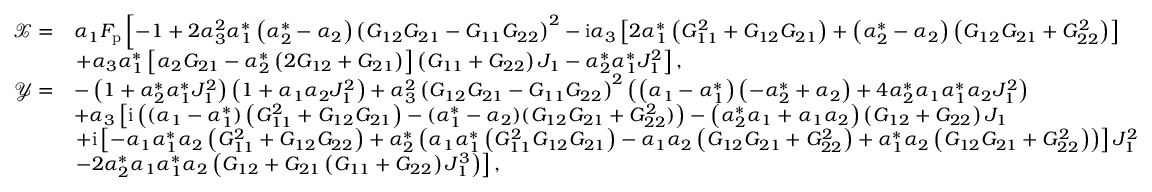<formula> <loc_0><loc_0><loc_500><loc_500>\begin{array} { r l } { \mathcal { X } = } & { \alpha _ { 1 } F _ { p } \left [ - 1 + 2 \alpha _ { 3 } ^ { 2 } \alpha _ { 1 } ^ { * } \left ( \alpha _ { 2 } ^ { * } - \alpha _ { 2 } \right ) \left ( G _ { 1 2 } G _ { 2 1 } - G _ { 1 1 } G _ { 2 2 } \right ) ^ { 2 } - i \alpha _ { 3 } \left [ 2 \alpha _ { 1 } ^ { * } \left ( G _ { 1 1 } ^ { 2 } + G _ { 1 2 } G _ { 2 1 } \right ) + \left ( \alpha _ { 2 } ^ { * } - \alpha _ { 2 } \right ) \left ( G _ { 1 2 } G _ { 2 1 } + G _ { 2 2 } ^ { 2 } \right ) \right ] } \\ & { + \alpha _ { 3 } \alpha _ { 1 } ^ { * } \left [ \alpha _ { 2 } G _ { 2 1 } - \alpha _ { 2 } ^ { * } \left ( 2 G _ { 1 2 } + G _ { 2 1 } \right ) \right ] \left ( G _ { 1 1 } + G _ { 2 2 } \right ) J _ { 1 } - \alpha _ { 2 } ^ { * } \alpha _ { 1 } ^ { * } J _ { 1 } ^ { 2 } \right ] , } \\ { \mathcal { Y } = } & { - \left ( 1 + \alpha _ { 2 } ^ { * } \alpha _ { 1 } ^ { * } J _ { 1 } ^ { 2 } \right ) \left ( 1 + \alpha _ { 1 } \alpha _ { 2 } J _ { 1 } ^ { 2 } \right ) + \alpha _ { 3 } ^ { 2 } \left ( G _ { 1 2 } G _ { 2 1 } - G _ { 1 1 } G _ { 2 2 } \right ) ^ { 2 } \left ( \left ( \alpha _ { 1 } - \alpha _ { 1 } ^ { * } \right ) \left ( - \alpha _ { 2 } ^ { * } + \alpha _ { 2 } \right ) + 4 \alpha _ { 2 } ^ { * } \alpha _ { 1 } \alpha _ { 1 } ^ { * } \alpha _ { 2 } J _ { 1 } ^ { 2 } \right ) } \\ & { + \alpha _ { 3 } \left [ i \left ( ( \alpha _ { 1 } - \alpha _ { 1 } ^ { * } ) \left ( G _ { 1 1 } ^ { 2 } + G _ { 1 2 } G _ { 2 1 } \right ) - ( \alpha _ { 1 } ^ { * } - \alpha _ { 2 } ) ( G _ { 1 2 } G _ { 2 1 } + G _ { 2 2 } ^ { 2 } ) \right ) - \left ( \alpha _ { 2 } ^ { * } \alpha _ { 1 } + \alpha _ { 1 } \alpha _ { 2 } \right ) \left ( G _ { 1 2 } + G _ { 2 2 } \right ) J _ { 1 } } \\ & { + i \left [ - \alpha _ { 1 } \alpha _ { 1 } ^ { * } \alpha _ { 2 } \left ( G _ { 1 1 } ^ { 2 } + G _ { 1 2 } G _ { 2 2 } \right ) + \alpha _ { 2 } ^ { * } \left ( \alpha _ { 1 } \alpha _ { 1 } ^ { * } \left ( G _ { 1 1 } ^ { 2 } G _ { 1 2 } G _ { 2 1 } \right ) - \alpha _ { 1 } \alpha _ { 2 } \left ( G _ { 1 2 } G _ { 2 1 } + G _ { 2 2 } ^ { 2 } \right ) + \alpha _ { 1 } ^ { * } \alpha _ { 2 } \left ( G _ { 1 2 } G _ { 2 1 } + G _ { 2 2 } ^ { 2 } \right ) \right ) \right ] J _ { 1 } ^ { 2 } } \\ & { - 2 \alpha _ { 2 } ^ { * } \alpha _ { 1 } \alpha _ { 1 } ^ { * } \alpha _ { 2 } \left ( G _ { 1 2 } + G _ { 2 1 } \left ( G _ { 1 1 } + G _ { 2 2 } \right ) J _ { 1 } ^ { 3 } \right ) \right ] , } \end{array}</formula> 